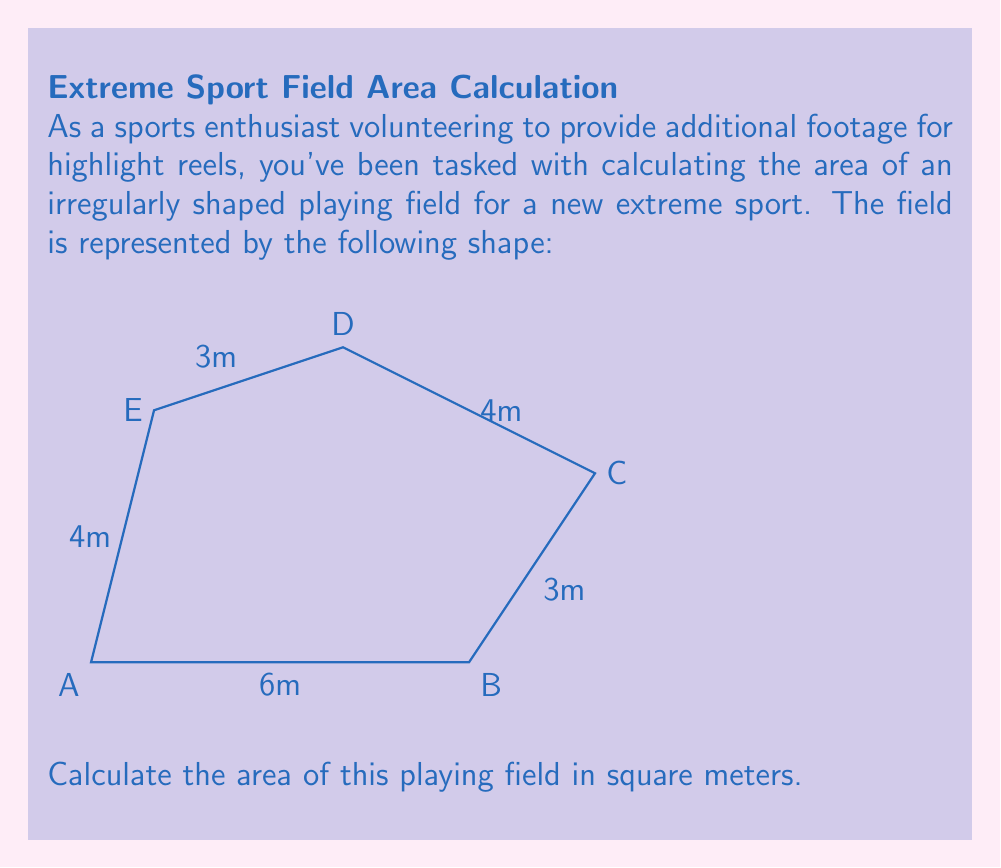Can you answer this question? To calculate the area of this irregular playing field, we can divide it into simpler shapes and use the formula for the area of a triangle. Let's break it down step-by-step:

1) Divide the field into three triangles: ABC, ACD, and ADE.

2) For triangle ABC:
   Base = 6m, Height = 3m
   Area_ABC = $\frac{1}{2} \times 6 \times 3 = 9$ sq m

3) For triangle ACD:
   We need to find its base and height.
   Base (AC) = $\sqrt{6^2 + 3^2} = \sqrt{45} = 3\sqrt{5}$ m
   Height can be found using the area of triangle BCD:
   Area_BCD = $\frac{1}{2} \times 2 \times 5 = 5$ sq m
   So, height of ACD = $\frac{2 \times 5}{3\sqrt{5}} = \frac{10}{3\sqrt{5}}$ m
   Area_ACD = $\frac{1}{2} \times 3\sqrt{5} \times \frac{10}{3\sqrt{5}} = 5$ sq m

4) For triangle ADE:
   Base = 4m, Height = 3m
   Area_ADE = $\frac{1}{2} \times 4 \times 3 = 6$ sq m

5) Total area = Area_ABC + Area_ACD + Area_ADE
               = 9 + 5 + 6 = 20 sq m
Answer: 20 sq m 